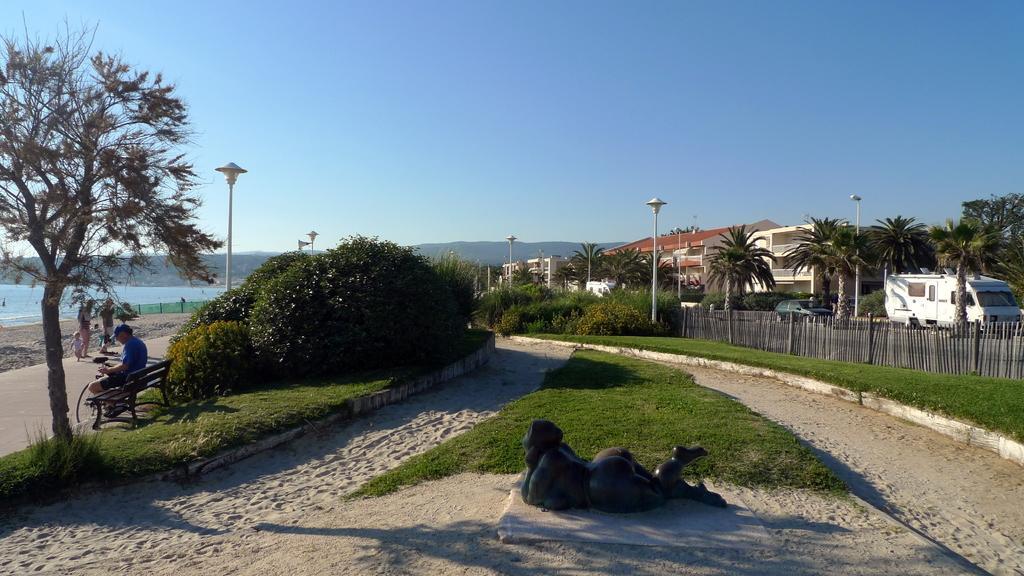How would you summarize this image in a sentence or two? n the center of the image we can see a statue. On the left side of the image we can see the water, floor and three people are standing and a man is sitting on a bench, in-front of him we can see a bicycle. In the background of the image we can see the hills, trees, buildings, poles, lights, vehicles, fence, grass. At the bottom of the image we can see the soil. At the top of the image we can see the sky. 